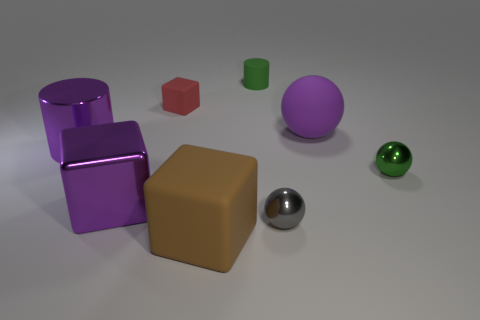Are there any large matte balls of the same color as the metal block?
Offer a very short reply. Yes. What is the material of the tiny ball that is the same color as the rubber cylinder?
Provide a short and direct response. Metal. The tiny object that is behind the tiny green metal sphere and in front of the tiny matte cylinder has what shape?
Keep it short and to the point. Cube. The large matte thing that is to the right of the rubber block in front of the big purple thing in front of the green ball is what shape?
Offer a terse response. Sphere. What is the material of the large purple thing that is both behind the green shiny thing and in front of the rubber ball?
Your answer should be very brief. Metal. How many gray spheres have the same size as the red thing?
Provide a short and direct response. 1. What number of matte things are either big blue cubes or brown cubes?
Your answer should be compact. 1. What is the material of the small green cylinder?
Your response must be concise. Rubber. How many big purple balls are behind the big purple rubber object?
Keep it short and to the point. 0. Do the big purple sphere in front of the tiny green rubber object and the brown thing have the same material?
Provide a short and direct response. Yes. 